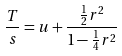<formula> <loc_0><loc_0><loc_500><loc_500>\frac { T } { s } = u + \frac { \frac { 1 } { 2 } r ^ { 2 } } { 1 - \frac { 1 } { 4 } r ^ { 2 } }</formula> 